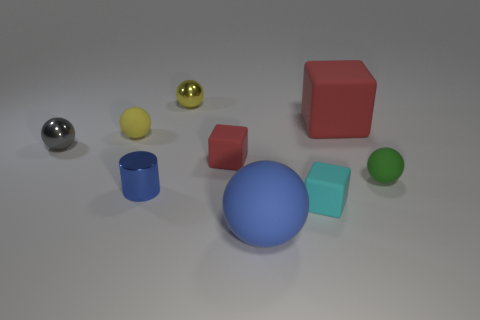Subtract 2 spheres. How many spheres are left? 3 Subtract all blue balls. How many balls are left? 4 Subtract all cyan balls. Subtract all gray blocks. How many balls are left? 5 Add 1 matte cylinders. How many objects exist? 10 Subtract all cylinders. How many objects are left? 8 Add 6 tiny cyan rubber things. How many tiny cyan rubber things are left? 7 Add 5 green rubber balls. How many green rubber balls exist? 6 Subtract 0 cyan cylinders. How many objects are left? 9 Subtract all tiny cyan rubber cubes. Subtract all tiny blocks. How many objects are left? 6 